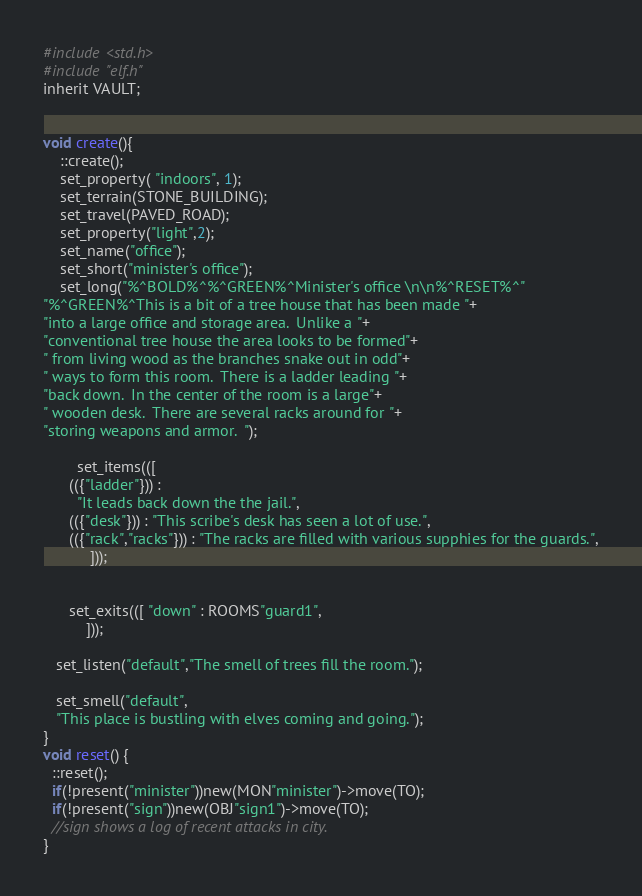<code> <loc_0><loc_0><loc_500><loc_500><_C_>#include <std.h>
#include "elf.h"
inherit VAULT;


void create(){
    ::create();
    set_property( "indoors", 1);
    set_terrain(STONE_BUILDING);
    set_travel(PAVED_ROAD);
	set_property("light",2);
    set_name("office");
    set_short("minister's office");
    set_long("%^BOLD%^%^GREEN%^Minister's office \n\n%^RESET%^"
"%^GREEN%^This is a bit of a tree house that has been made "+
"into a large office and storage area.  Unlike a "+
"conventional tree house the area looks to be formed"+
" from living wood as the branches snake out in odd"+
" ways to form this room.  There is a ladder leading "+
"back down.  In the center of the room is a large"+
" wooden desk.  There are several racks around for "+
"storing weapons and armor.  ");

        set_items(([
      (({"ladder"})) :
        "It leads back down the the jail.",
      (({"desk"})) : "This scribe's desk has seen a lot of use.",
      (({"rack","racks"})) : "The racks are filled with various supphies for the guards.",
           ]));

   
      set_exits(([ "down" : ROOMS"guard1",
          ]));

   set_listen("default","The smell of trees fill the room.");

   set_smell("default",
   "This place is bustling with elves coming and going.");
}
void reset() {
  ::reset();
  if(!present("minister"))new(MON"minister")->move(TO);
  if(!present("sign"))new(OBJ"sign1")->move(TO);
  //sign shows a log of recent attacks in city.
}
</code> 